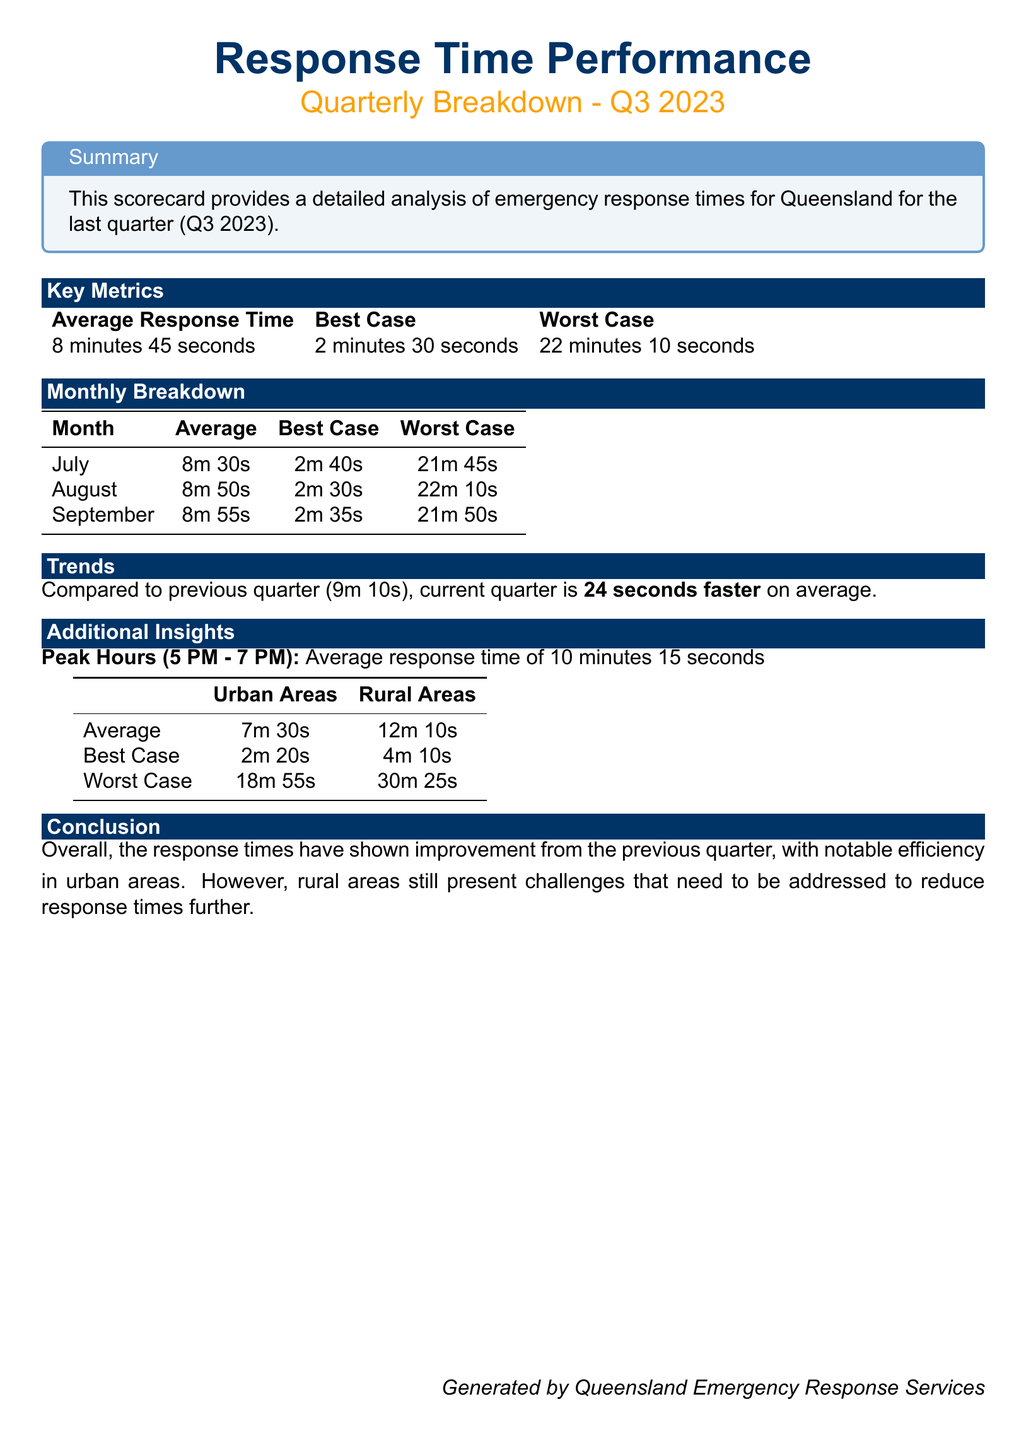what is the average response time for Q3 2023? The average response time for Q3 2023 is stated in the key metrics section of the document.
Answer: 8 minutes 45 seconds what was the best-case response time in September? The best-case response time for September can be found in the monthly breakdown section of the document.
Answer: 2 minutes 35 seconds how much faster is the current quarter compared to the previous quarter? The document provides a comparison between the current quarter and the previous one, indicating the difference in average response times.
Answer: 24 seconds faster what is the worst-case response time reported for urban areas? The worst-case response time for urban areas is provided in the additional insights section of the document.
Answer: 18 minutes 55 seconds what was the average response time during peak hours? The peak hours average is highlighted in the additional insights part of the scorecard.
Answer: 10 minutes 15 seconds which month had the worst-case response time of 22 minutes 10 seconds? The worst-case response time for one of the months is listed in the monthly breakdown section of the document.
Answer: August what is the average response time in rural areas? The average response time for rural areas is mentioned in the additional insights of the document.
Answer: 12 minutes 10 seconds who generated this scorecard? The last section of the document credits the entity responsible for generating the scorecard.
Answer: Queensland Emergency Response Services 